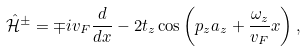Convert formula to latex. <formula><loc_0><loc_0><loc_500><loc_500>\mathcal { \hat { H } } ^ { \pm } = \mp i v _ { F } \frac { d } { d x } - 2 t _ { z } \cos \left ( p _ { z } a _ { z } + \frac { \omega _ { z } } { v _ { F } } x \right ) ,</formula> 